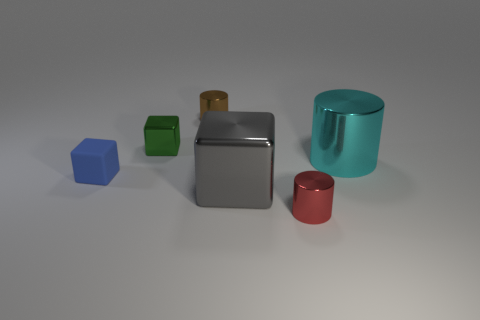Are there any big gray metallic things that have the same shape as the tiny green object?
Make the answer very short. Yes. Is there a big cyan metallic cylinder in front of the large shiny thing in front of the cyan cylinder?
Your response must be concise. No. What number of other tiny brown cylinders have the same material as the tiny brown cylinder?
Your answer should be compact. 0. Is there a matte block?
Provide a short and direct response. Yes. Do the red object and the tiny cylinder behind the red object have the same material?
Offer a very short reply. Yes. Are there more big gray shiny things behind the tiny green object than tiny green shiny cubes?
Ensure brevity in your answer.  No. Is there anything else that is the same size as the cyan cylinder?
Provide a succinct answer. Yes. There is a rubber block; does it have the same color as the small cylinder in front of the large gray metal cube?
Your answer should be compact. No. Are there an equal number of small red metal cylinders in front of the tiny red thing and blue objects on the right side of the tiny brown shiny cylinder?
Provide a succinct answer. Yes. There is a tiny cylinder that is in front of the brown metal cylinder; what is its material?
Offer a terse response. Metal. 